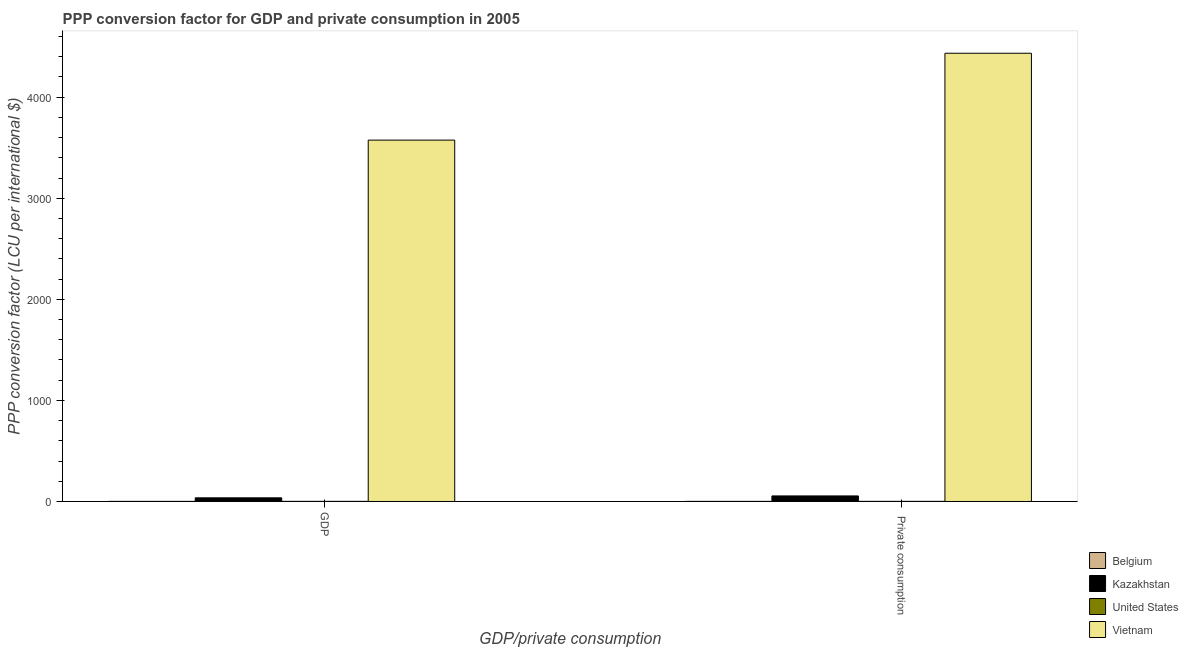How many different coloured bars are there?
Your answer should be very brief. 4. Are the number of bars on each tick of the X-axis equal?
Your answer should be compact. Yes. How many bars are there on the 1st tick from the left?
Your answer should be very brief. 4. What is the label of the 1st group of bars from the left?
Ensure brevity in your answer.  GDP. What is the ppp conversion factor for gdp in Belgium?
Your answer should be very brief. 0.9. Across all countries, what is the maximum ppp conversion factor for private consumption?
Ensure brevity in your answer.  4434.71. Across all countries, what is the minimum ppp conversion factor for private consumption?
Offer a terse response. 0.92. In which country was the ppp conversion factor for gdp maximum?
Keep it short and to the point. Vietnam. What is the total ppp conversion factor for gdp in the graph?
Make the answer very short. 3613.03. What is the difference between the ppp conversion factor for private consumption in Kazakhstan and that in Belgium?
Provide a succinct answer. 53.95. What is the difference between the ppp conversion factor for gdp in United States and the ppp conversion factor for private consumption in Vietnam?
Give a very brief answer. -4433.71. What is the average ppp conversion factor for gdp per country?
Ensure brevity in your answer.  903.26. What is the difference between the ppp conversion factor for gdp and ppp conversion factor for private consumption in United States?
Your response must be concise. 0. In how many countries, is the ppp conversion factor for private consumption greater than 2600 LCU?
Provide a succinct answer. 1. What is the ratio of the ppp conversion factor for private consumption in Belgium to that in United States?
Make the answer very short. 0.92. Is the ppp conversion factor for gdp in Belgium less than that in Vietnam?
Provide a short and direct response. Yes. In how many countries, is the ppp conversion factor for private consumption greater than the average ppp conversion factor for private consumption taken over all countries?
Provide a short and direct response. 1. What does the 4th bar from the right in  Private consumption represents?
Provide a succinct answer. Belgium. Are all the bars in the graph horizontal?
Your response must be concise. No. Does the graph contain grids?
Ensure brevity in your answer.  No. Where does the legend appear in the graph?
Your answer should be very brief. Bottom right. How many legend labels are there?
Your answer should be compact. 4. What is the title of the graph?
Your response must be concise. PPP conversion factor for GDP and private consumption in 2005. What is the label or title of the X-axis?
Ensure brevity in your answer.  GDP/private consumption. What is the label or title of the Y-axis?
Your response must be concise. PPP conversion factor (LCU per international $). What is the PPP conversion factor (LCU per international $) of Belgium in GDP?
Your answer should be very brief. 0.9. What is the PPP conversion factor (LCU per international $) in Kazakhstan in GDP?
Give a very brief answer. 36.03. What is the PPP conversion factor (LCU per international $) of United States in GDP?
Your response must be concise. 1. What is the PPP conversion factor (LCU per international $) of Vietnam in GDP?
Your answer should be very brief. 3575.1. What is the PPP conversion factor (LCU per international $) of Belgium in  Private consumption?
Your answer should be very brief. 0.92. What is the PPP conversion factor (LCU per international $) of Kazakhstan in  Private consumption?
Your answer should be compact. 54.88. What is the PPP conversion factor (LCU per international $) of Vietnam in  Private consumption?
Offer a terse response. 4434.71. Across all GDP/private consumption, what is the maximum PPP conversion factor (LCU per international $) of Belgium?
Provide a short and direct response. 0.92. Across all GDP/private consumption, what is the maximum PPP conversion factor (LCU per international $) in Kazakhstan?
Keep it short and to the point. 54.88. Across all GDP/private consumption, what is the maximum PPP conversion factor (LCU per international $) in United States?
Provide a short and direct response. 1. Across all GDP/private consumption, what is the maximum PPP conversion factor (LCU per international $) of Vietnam?
Your answer should be very brief. 4434.71. Across all GDP/private consumption, what is the minimum PPP conversion factor (LCU per international $) of Belgium?
Your answer should be very brief. 0.9. Across all GDP/private consumption, what is the minimum PPP conversion factor (LCU per international $) of Kazakhstan?
Offer a terse response. 36.03. Across all GDP/private consumption, what is the minimum PPP conversion factor (LCU per international $) in Vietnam?
Keep it short and to the point. 3575.1. What is the total PPP conversion factor (LCU per international $) in Belgium in the graph?
Keep it short and to the point. 1.82. What is the total PPP conversion factor (LCU per international $) in Kazakhstan in the graph?
Keep it short and to the point. 90.91. What is the total PPP conversion factor (LCU per international $) of United States in the graph?
Offer a terse response. 2. What is the total PPP conversion factor (LCU per international $) of Vietnam in the graph?
Your answer should be compact. 8009.81. What is the difference between the PPP conversion factor (LCU per international $) of Belgium in GDP and that in  Private consumption?
Provide a succinct answer. -0.02. What is the difference between the PPP conversion factor (LCU per international $) in Kazakhstan in GDP and that in  Private consumption?
Provide a succinct answer. -18.84. What is the difference between the PPP conversion factor (LCU per international $) in United States in GDP and that in  Private consumption?
Provide a short and direct response. 0. What is the difference between the PPP conversion factor (LCU per international $) in Vietnam in GDP and that in  Private consumption?
Provide a succinct answer. -859.61. What is the difference between the PPP conversion factor (LCU per international $) in Belgium in GDP and the PPP conversion factor (LCU per international $) in Kazakhstan in  Private consumption?
Ensure brevity in your answer.  -53.98. What is the difference between the PPP conversion factor (LCU per international $) in Belgium in GDP and the PPP conversion factor (LCU per international $) in United States in  Private consumption?
Your answer should be compact. -0.1. What is the difference between the PPP conversion factor (LCU per international $) in Belgium in GDP and the PPP conversion factor (LCU per international $) in Vietnam in  Private consumption?
Offer a very short reply. -4433.81. What is the difference between the PPP conversion factor (LCU per international $) in Kazakhstan in GDP and the PPP conversion factor (LCU per international $) in United States in  Private consumption?
Make the answer very short. 35.03. What is the difference between the PPP conversion factor (LCU per international $) of Kazakhstan in GDP and the PPP conversion factor (LCU per international $) of Vietnam in  Private consumption?
Make the answer very short. -4398.68. What is the difference between the PPP conversion factor (LCU per international $) in United States in GDP and the PPP conversion factor (LCU per international $) in Vietnam in  Private consumption?
Give a very brief answer. -4433.71. What is the average PPP conversion factor (LCU per international $) of Belgium per GDP/private consumption?
Provide a succinct answer. 0.91. What is the average PPP conversion factor (LCU per international $) in Kazakhstan per GDP/private consumption?
Your answer should be compact. 45.46. What is the average PPP conversion factor (LCU per international $) of United States per GDP/private consumption?
Provide a short and direct response. 1. What is the average PPP conversion factor (LCU per international $) in Vietnam per GDP/private consumption?
Ensure brevity in your answer.  4004.91. What is the difference between the PPP conversion factor (LCU per international $) in Belgium and PPP conversion factor (LCU per international $) in Kazakhstan in GDP?
Provide a succinct answer. -35.13. What is the difference between the PPP conversion factor (LCU per international $) of Belgium and PPP conversion factor (LCU per international $) of United States in GDP?
Provide a succinct answer. -0.1. What is the difference between the PPP conversion factor (LCU per international $) of Belgium and PPP conversion factor (LCU per international $) of Vietnam in GDP?
Your answer should be very brief. -3574.2. What is the difference between the PPP conversion factor (LCU per international $) of Kazakhstan and PPP conversion factor (LCU per international $) of United States in GDP?
Provide a short and direct response. 35.03. What is the difference between the PPP conversion factor (LCU per international $) of Kazakhstan and PPP conversion factor (LCU per international $) of Vietnam in GDP?
Your response must be concise. -3539.07. What is the difference between the PPP conversion factor (LCU per international $) of United States and PPP conversion factor (LCU per international $) of Vietnam in GDP?
Offer a very short reply. -3574.1. What is the difference between the PPP conversion factor (LCU per international $) in Belgium and PPP conversion factor (LCU per international $) in Kazakhstan in  Private consumption?
Provide a succinct answer. -53.95. What is the difference between the PPP conversion factor (LCU per international $) in Belgium and PPP conversion factor (LCU per international $) in United States in  Private consumption?
Offer a very short reply. -0.08. What is the difference between the PPP conversion factor (LCU per international $) of Belgium and PPP conversion factor (LCU per international $) of Vietnam in  Private consumption?
Ensure brevity in your answer.  -4433.79. What is the difference between the PPP conversion factor (LCU per international $) in Kazakhstan and PPP conversion factor (LCU per international $) in United States in  Private consumption?
Your answer should be very brief. 53.88. What is the difference between the PPP conversion factor (LCU per international $) in Kazakhstan and PPP conversion factor (LCU per international $) in Vietnam in  Private consumption?
Make the answer very short. -4379.84. What is the difference between the PPP conversion factor (LCU per international $) in United States and PPP conversion factor (LCU per international $) in Vietnam in  Private consumption?
Your answer should be very brief. -4433.71. What is the ratio of the PPP conversion factor (LCU per international $) of Belgium in GDP to that in  Private consumption?
Provide a short and direct response. 0.97. What is the ratio of the PPP conversion factor (LCU per international $) of Kazakhstan in GDP to that in  Private consumption?
Provide a succinct answer. 0.66. What is the ratio of the PPP conversion factor (LCU per international $) in United States in GDP to that in  Private consumption?
Give a very brief answer. 1. What is the ratio of the PPP conversion factor (LCU per international $) in Vietnam in GDP to that in  Private consumption?
Offer a terse response. 0.81. What is the difference between the highest and the second highest PPP conversion factor (LCU per international $) of Belgium?
Make the answer very short. 0.02. What is the difference between the highest and the second highest PPP conversion factor (LCU per international $) of Kazakhstan?
Ensure brevity in your answer.  18.84. What is the difference between the highest and the second highest PPP conversion factor (LCU per international $) in United States?
Your response must be concise. 0. What is the difference between the highest and the second highest PPP conversion factor (LCU per international $) of Vietnam?
Keep it short and to the point. 859.61. What is the difference between the highest and the lowest PPP conversion factor (LCU per international $) in Belgium?
Keep it short and to the point. 0.02. What is the difference between the highest and the lowest PPP conversion factor (LCU per international $) in Kazakhstan?
Your answer should be very brief. 18.84. What is the difference between the highest and the lowest PPP conversion factor (LCU per international $) in United States?
Make the answer very short. 0. What is the difference between the highest and the lowest PPP conversion factor (LCU per international $) in Vietnam?
Provide a succinct answer. 859.61. 